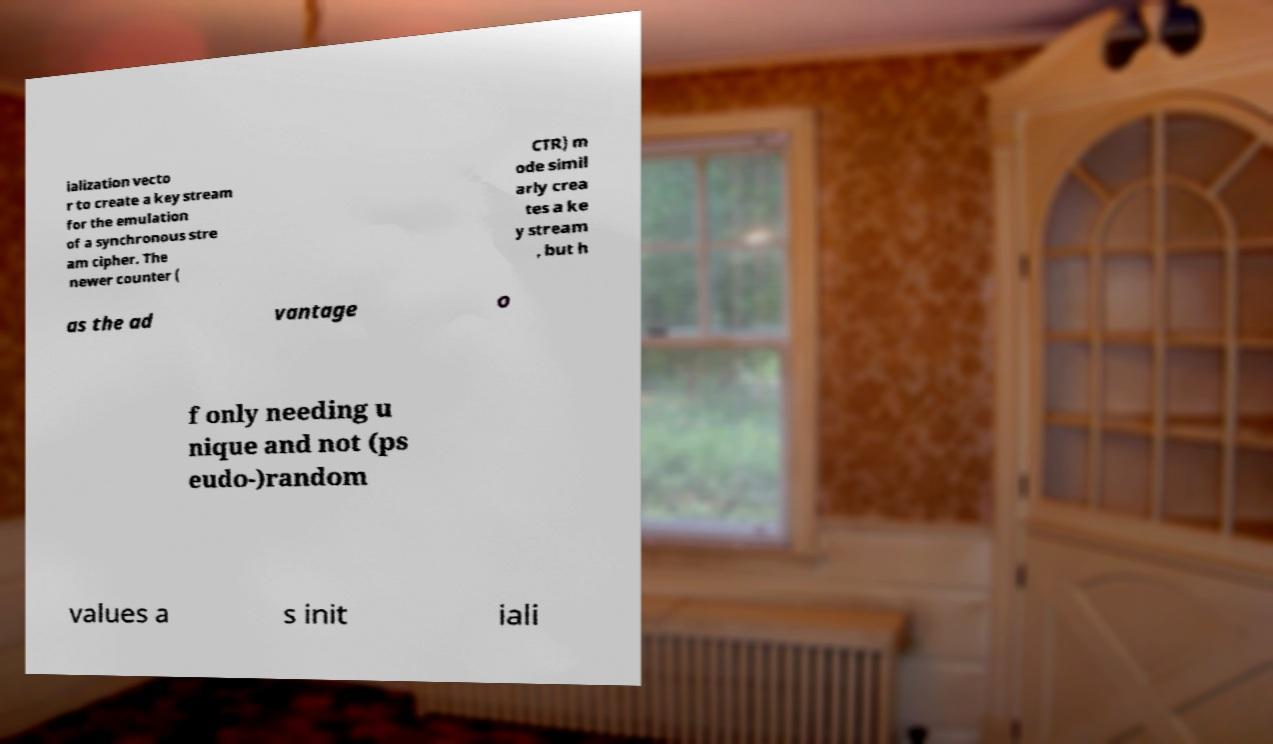For documentation purposes, I need the text within this image transcribed. Could you provide that? ialization vecto r to create a key stream for the emulation of a synchronous stre am cipher. The newer counter ( CTR) m ode simil arly crea tes a ke y stream , but h as the ad vantage o f only needing u nique and not (ps eudo-)random values a s init iali 